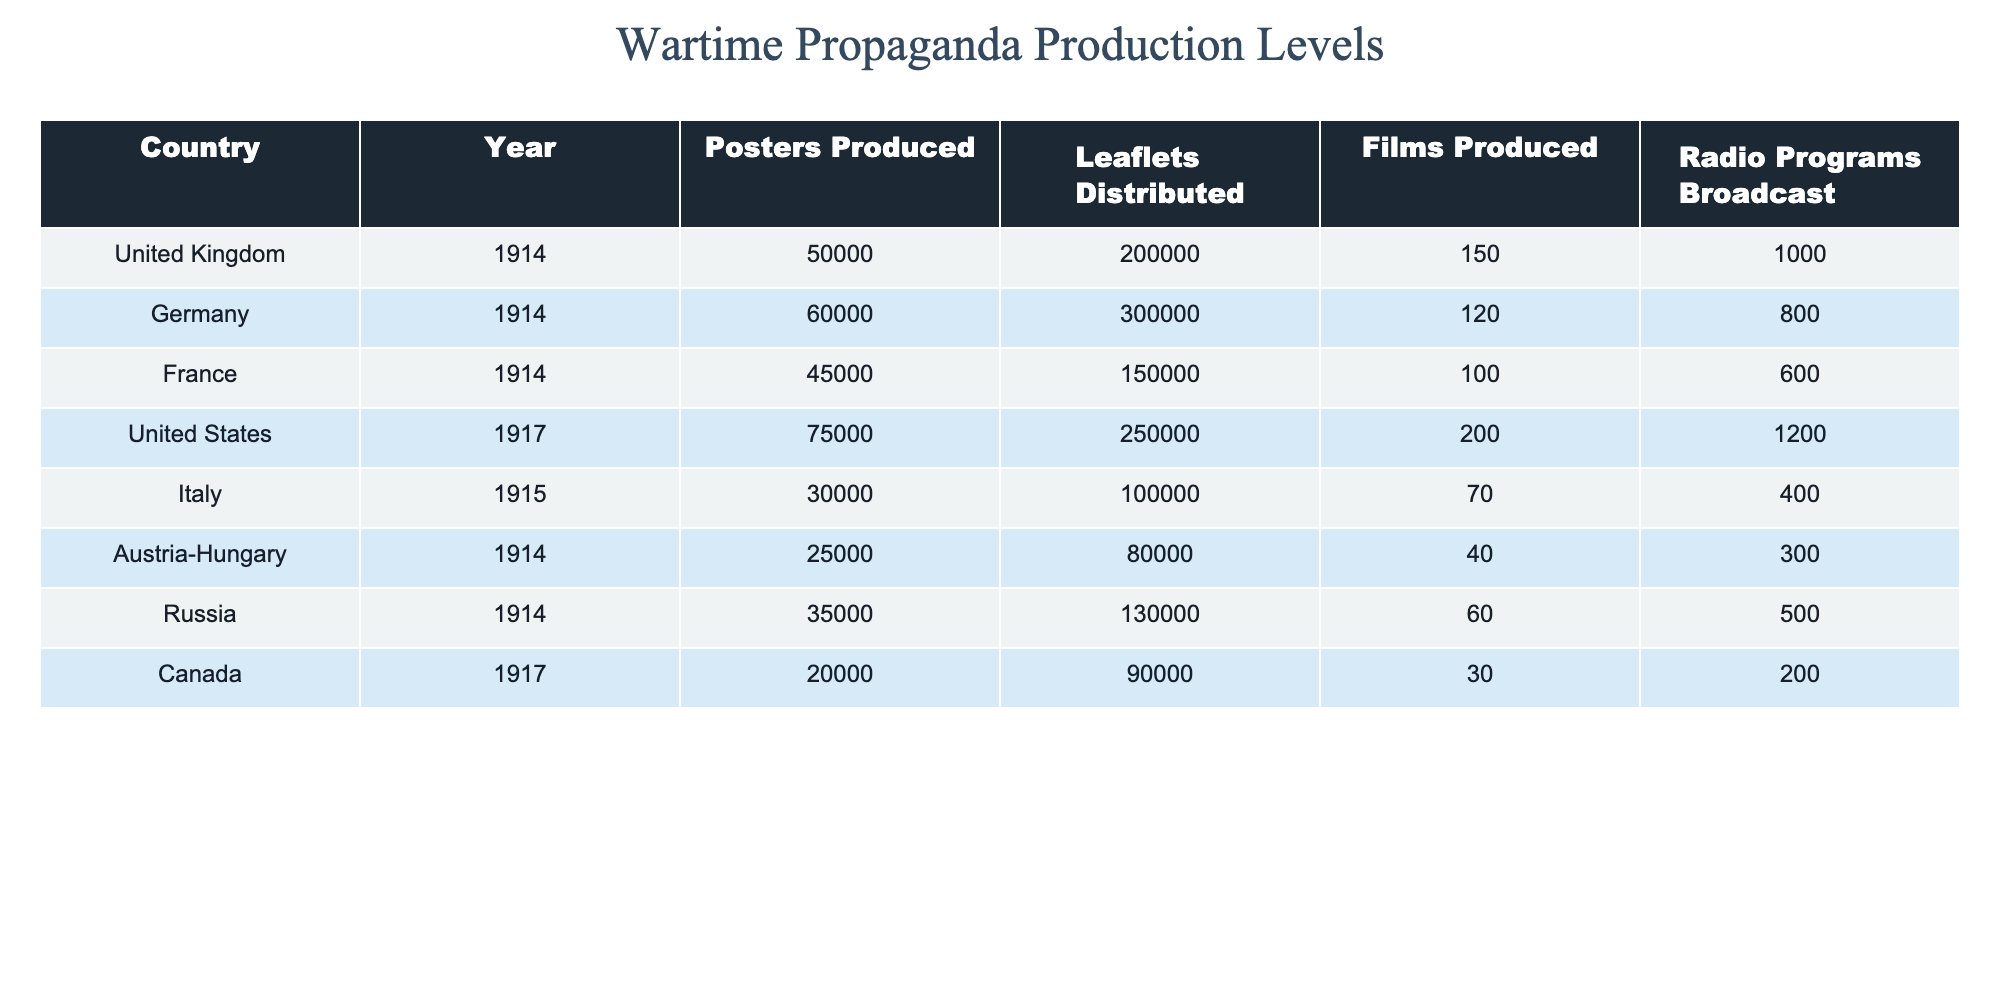What country produced the most posters in 1914? Looking at the table, Germany produced 60,000 posters in 1914, which is higher than the other countries listed for that year.
Answer: Germany What is the total number of leaflets distributed by the United Kingdom and France in 1914? The United Kingdom distributed 200,000 leaflets, and France distributed 150,000 leaflets. Adding these gives a total of 200,000 + 150,000 = 350,000 leaflets.
Answer: 350,000 Did Austria-Hungary produce more films than Italy in 1914? Austria-Hungary produced 40 films while Italy produced 70 films. Since 70 is greater than 40, the statement is false.
Answer: No Which country broadcast the least number of radio programs in 1917? In 1917, Canada broadcasted 200 radio programs, which is less than the other countries in that specific year.
Answer: Canada What is the average number of posters produced by the countries in 1914? To find the average, we sum the posters produced by all countries in 1914: 50,000 (UK) + 60,000 (Germany) + 45,000 (France) + 25,000 (Austria-Hungary) + 35,000 (Russia) = 215,000. There are 6 countries, thus the average is 215,000 / 6 ≈ 35,833.
Answer: Approx. 35,833 Which two countries had the highest production of films in 1917? The United States produced 200 films, while Canada produced 30 films in 1917. Therefore, the United States had the highest production, followed by Canada. The focus should be on identifying just the highest-producing country, which is the U.S.
Answer: United States If you combine the leaflets distributed by the United States and Italy, does that exceed the total from Germany and Russia? The United States distributed 250,000 leaflets, and Italy distributed 100,000, giving a total of 250,000 + 100,000 = 350,000. Germany distributed 300,000, while Russia distributed 130,000, giving a total of 300,000 + 130,000 = 430,000. Since 350,000 is less than 430,000, the answer is no.
Answer: No Which country had the most varied types of propaganda production (considering posters, leaflets, films, and radio)? To find the most varied, we'd check each country's output across different media. The United Kingdom and Germany both produced outgoing materials across all categories but had distinct quantities. However, Germany consistently had higher amounts (posters, leaflets) particularly in 1914 compared to others indicating higher variety outputs.
Answer: Germany 